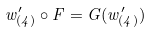<formula> <loc_0><loc_0><loc_500><loc_500>w ^ { \prime } _ { ( 4 ) } \circ F = G ( w ^ { \prime } _ { ( 4 ) } )</formula> 